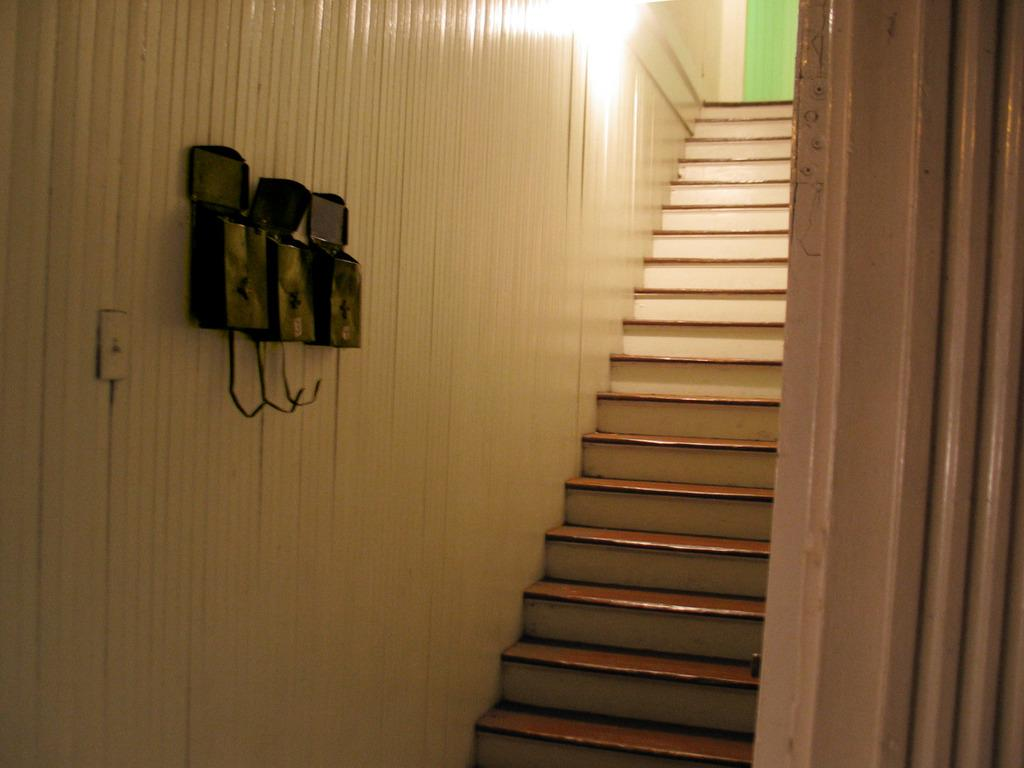What type of structure is present in the image? There is a staircase in the image. What can be seen on the left side of the image? There is a wall on the left side of the image. What is attached to the wall in the image? There is a lamp on the wall. What is the topic of the heated discussion taking place on the staircase in the image? There is no discussion taking place in the image; it only shows a staircase, a wall, and a lamp. 